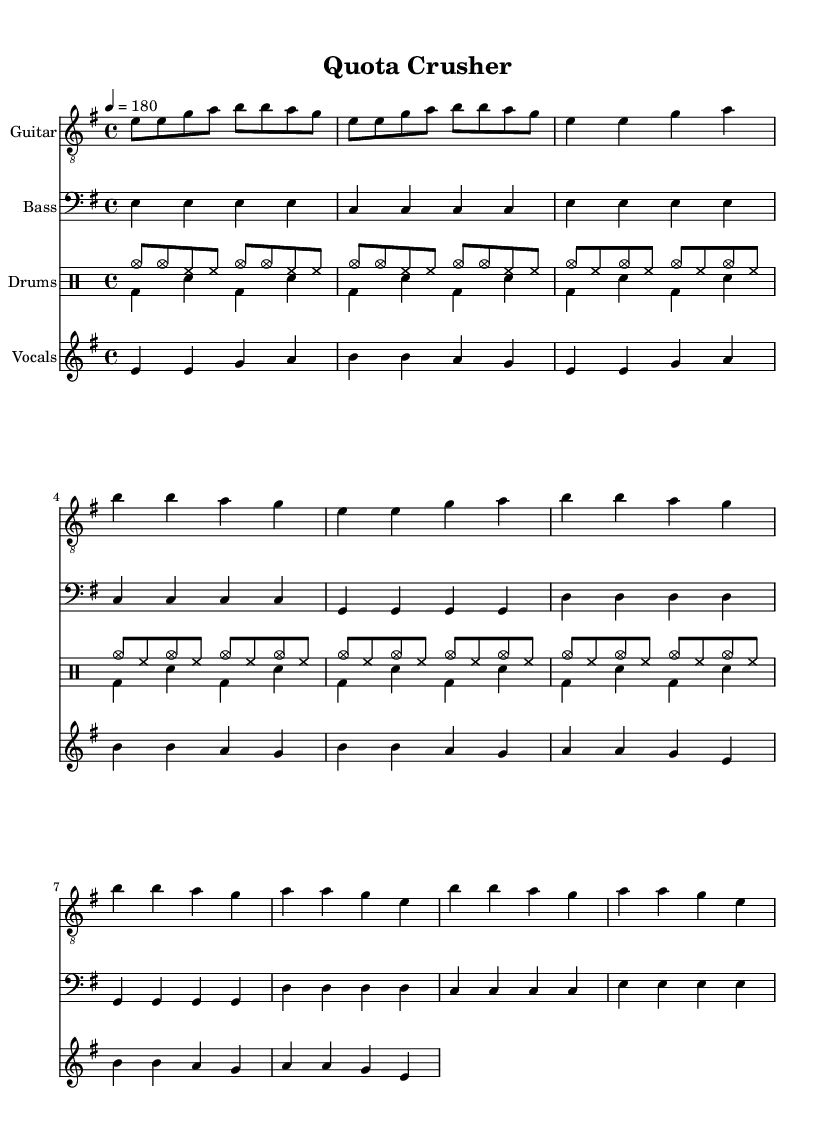What is the key signature of this music? The key signature is E minor, which contains one sharp, F#. This is indicated in the global section where the key is specified.
Answer: E minor What is the time signature of this music? The time signature is 4/4, which means there are four beats per measure. This can be found in the global section as well, right next to the key signature.
Answer: 4/4 What is the tempo marking of the piece? The tempo marking is 180, which indicates a fast speed. This is found in the global section under the tempo indication.
Answer: 180 What is the structure of the song? The song follows a structure that consists of an intro, verse, and chorus. This is determined by the distinct labeling and layout of the music notation, where each section clearly has differing lengths and repetitions.
Answer: Intro, Verse 1, Chorus How many measures are in the chorus? There are four measures in the chorus, which can be counted by looking at the specific notation labeled as the chorus section. Each line of music represents one measure, and this can be visually confirmed in the sheet music.
Answer: 4 What themes are being addressed in the lyrics? The lyrics discuss the pressures and challenges related to meeting sales quotas and targets. This thematic content relates directly to the lifestyle and challenges a sales representative faces, especially the mention of “Crush the quota” and “High-end pet food is my claim to fame.”
Answer: Sales quotas and targets 